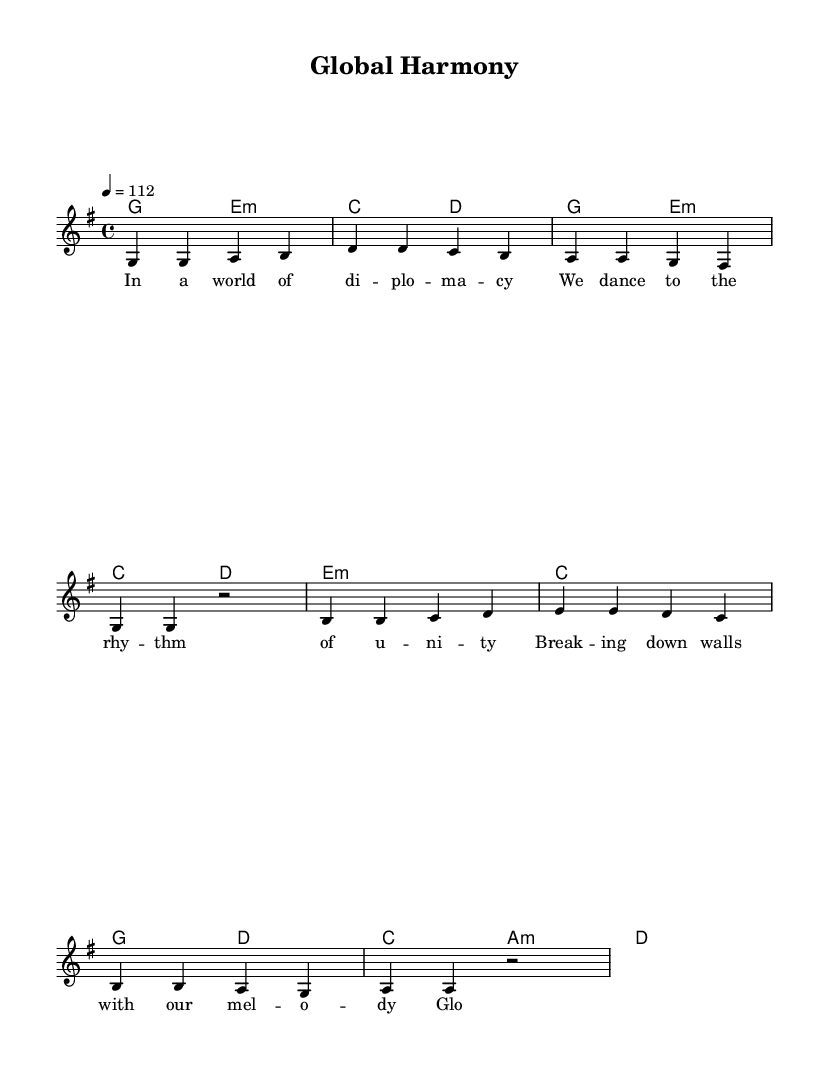What is the key signature of this music? The key signature is G major, which has one sharp (F#). This is identified by looking at the beginning of the sheet music, where the key signature is notated.
Answer: G major What is the time signature of this music? The time signature is 4/4, indicated at the beginning of the score. This tells us that there are four beats per measure and the quarter note gets one beat.
Answer: 4/4 What is the tempo indication for this piece? The tempo is marked at 112 beats per minute, as stated in the tempo marking. This dictates the speed at which the piece should be performed.
Answer: 112 How many measures are in the melody section? The melody section has eight measures in total, as counted from the beginning to the end of the indicated melody lines.
Answer: Eight Identify the first chord used in the harmony section. The first chord in the harmony section is G major, which is the chord played at the start of the harmony line. This is typically indicated in the chord mode notation.
Answer: G What theme is reflected in the lyrics of this piece? The lyrics reflect themes of diplomacy and unity, as indicated by lines discussing breaking down walls and global harmony. This thematic content is consistent with concerns of international relations.
Answer: Diplomacy Which type of lyrics structure is used in this song? The lyrics are structured in a verse format, with several lines that rhyme and convey a message. This is typical layout for Latin pop, where emotional themes are expressed in a melodic fashion.
Answer: Verse structure 